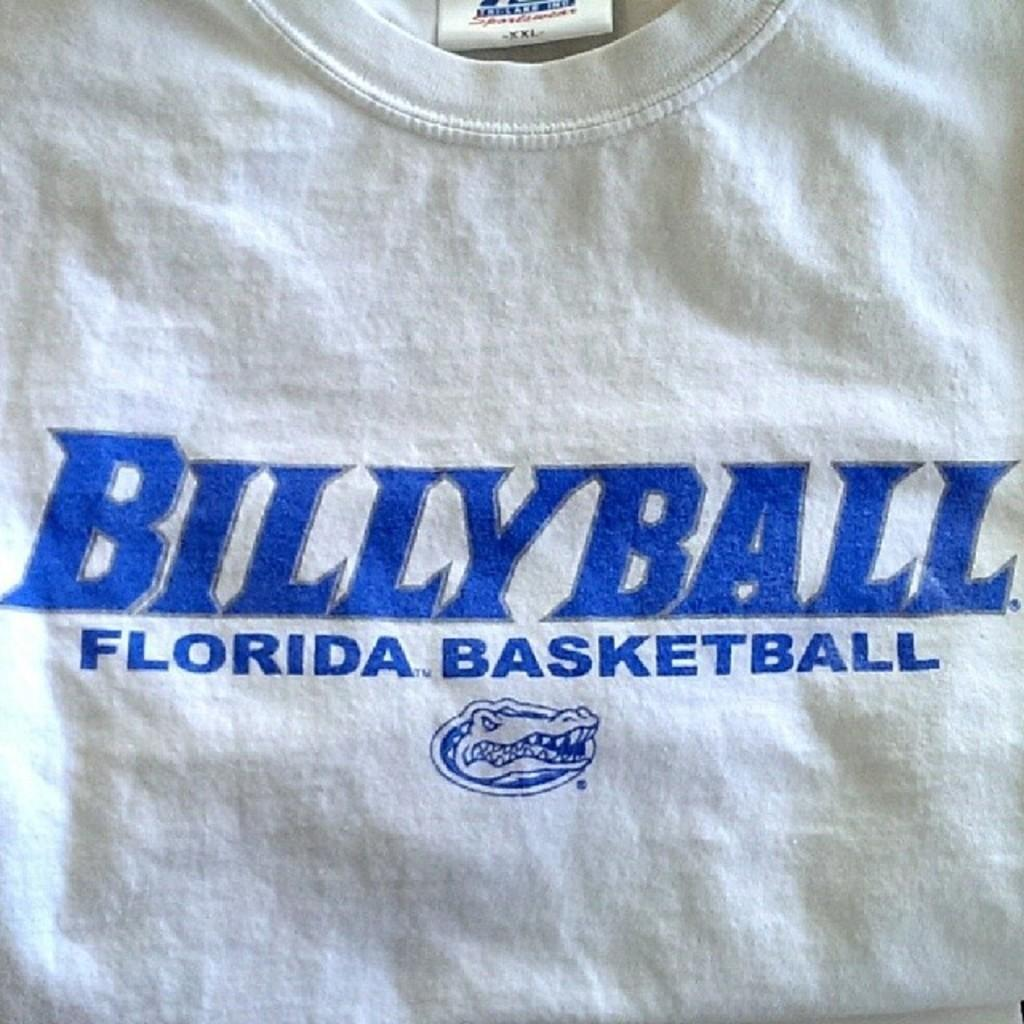<image>
Render a clear and concise summary of the photo. The shirt has BILLYBALL FLORIDA BASKETBALL written on it with an alligator face. 